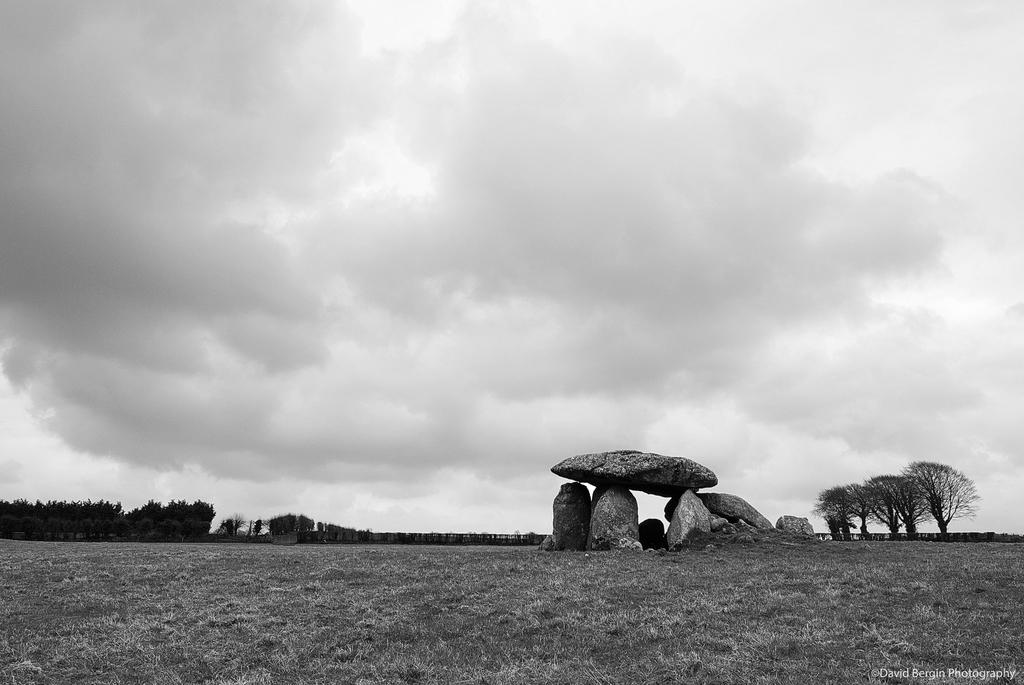What type of vegetation can be seen in the image? There is grass in the image. What other natural elements are present in the image? There are rocks and trees in the image. Can you describe the objects in the image? There are objects in the image, but their specific nature is not mentioned in the facts. What is visible in the background of the image? The sky is visible in the background of the image. What can be seen in the sky? Clouds are present in the sky. What time of day is it in the image, and how does the grass feel in the morning? The time of day is not mentioned in the facts, and the grass's texture in the morning cannot be determined from the image. 